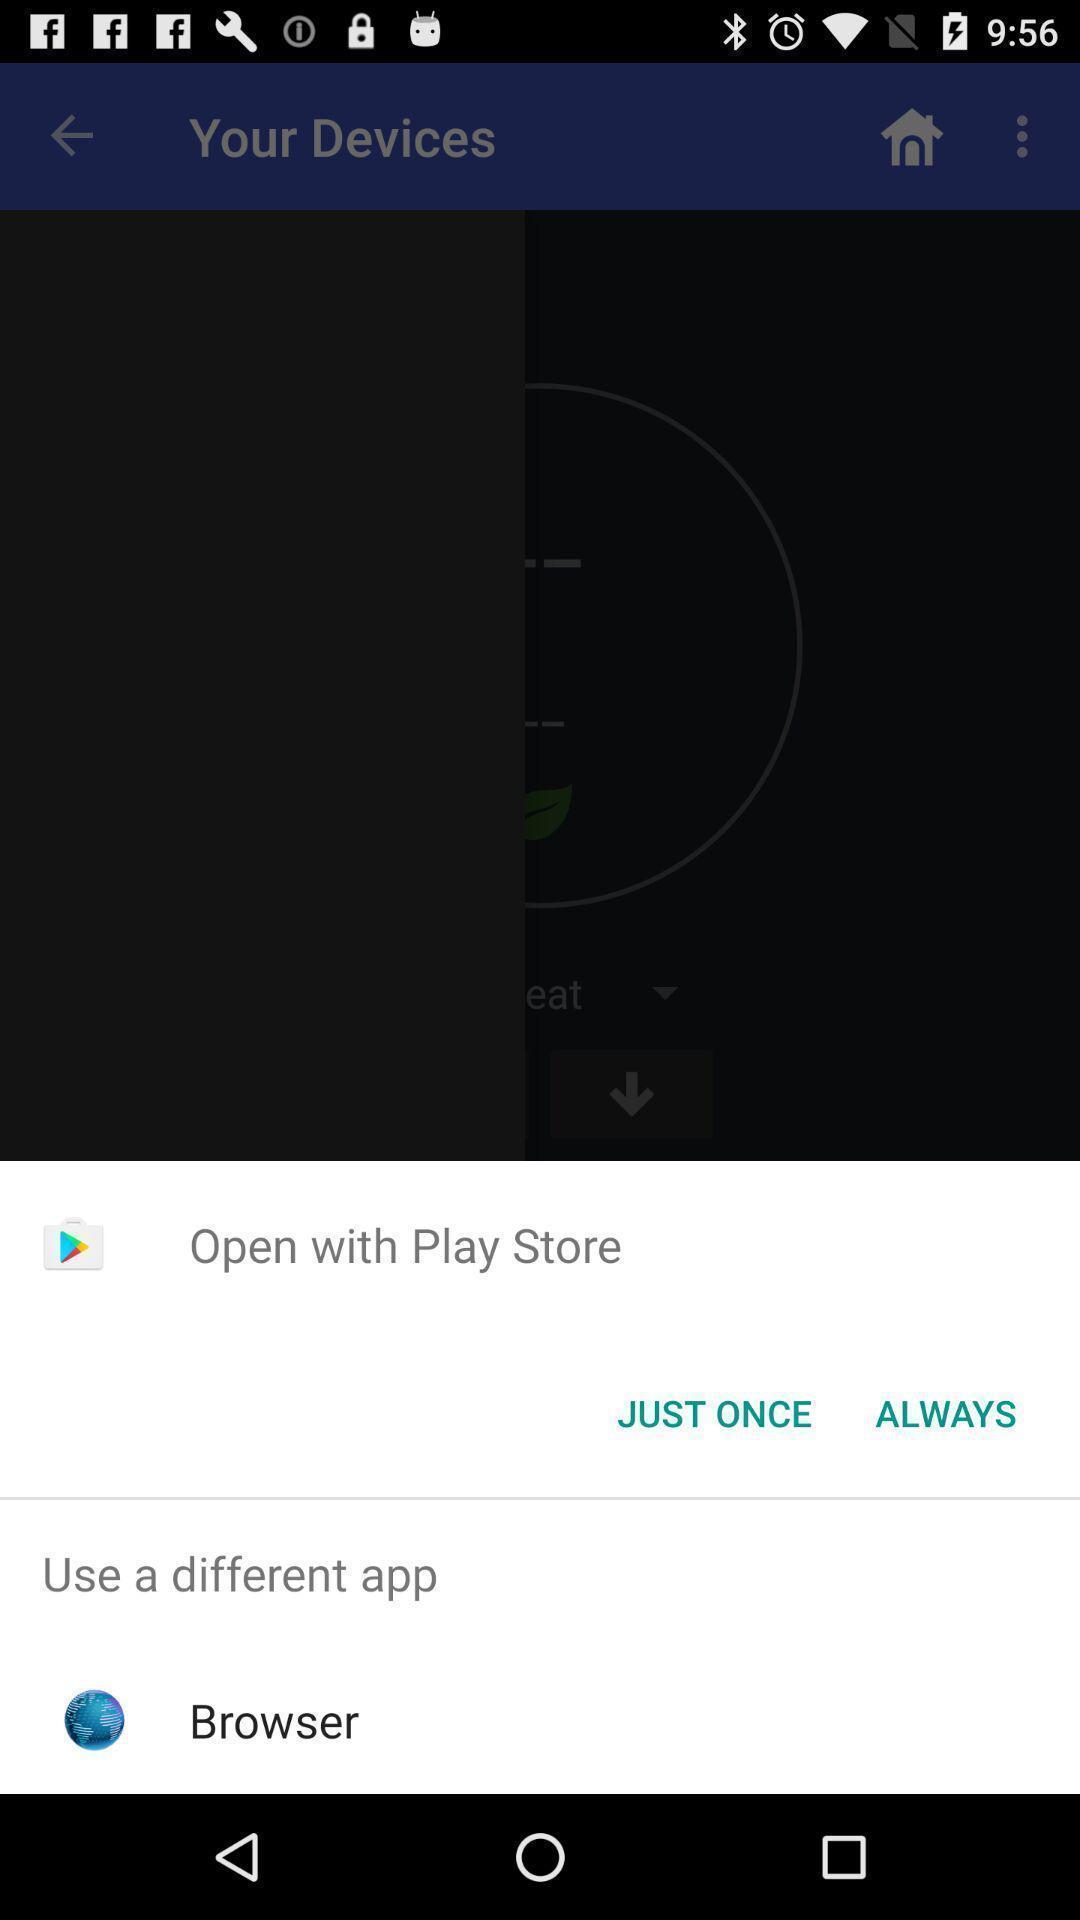Describe this image in words. Pop up displaying to open the page. 